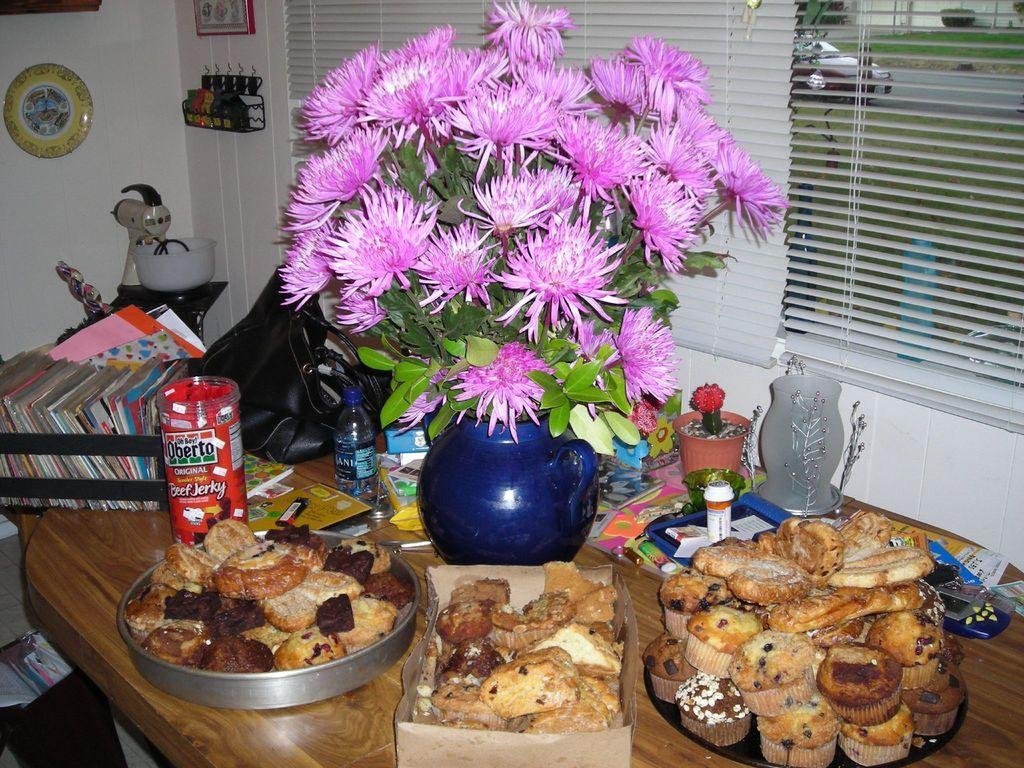Could you give a brief overview of what you see in this image? In this image I can see a table. On this table few plates, bottles, flower pot and some dishes are placed. In the background I can see a wall and window. 